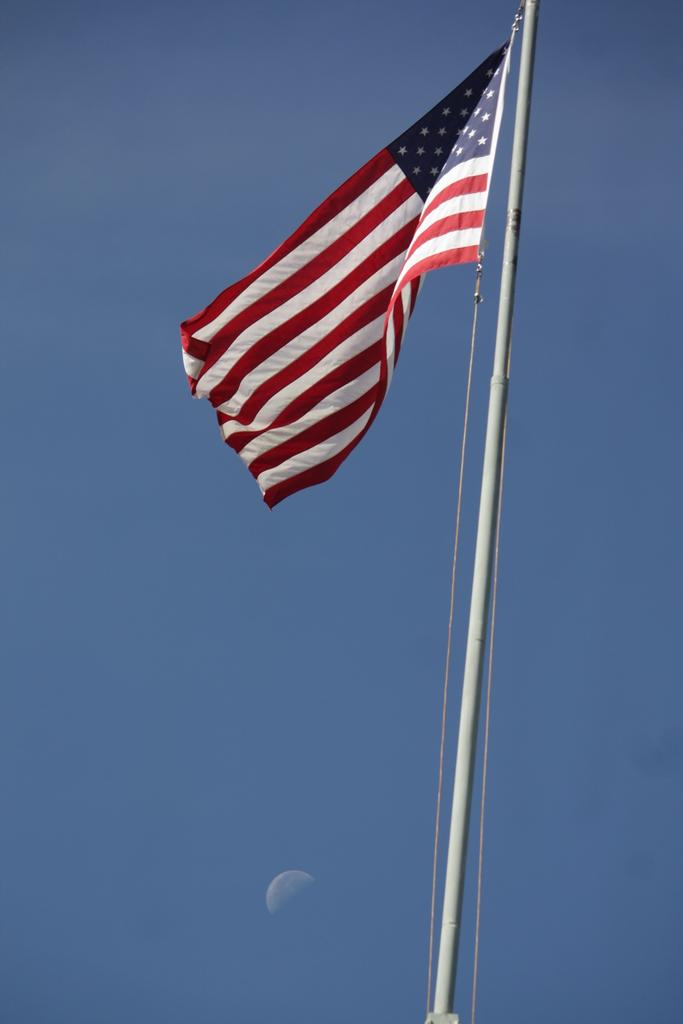What can be seen flying or waving in the image? There is a flag in the image. What celestial body is visible in the sky in the image? There is a moon visible in the sky in the image. What type of vacation is being advertised by the squirrel playing the drum in the image? There is no squirrel or drum present in the image, so this question cannot be answered. 